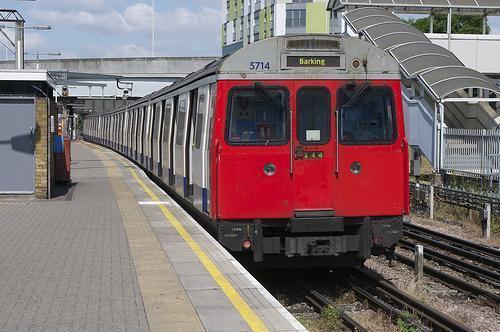How many windows are shown?
Give a very brief answer. 3. 